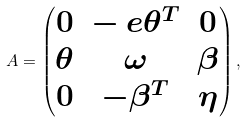Convert formula to latex. <formula><loc_0><loc_0><loc_500><loc_500>A = \begin{pmatrix} 0 & - \ e \theta ^ { T } & 0 \\ \theta & \omega & \beta \\ 0 & - \beta ^ { T } & \eta \end{pmatrix} ,</formula> 